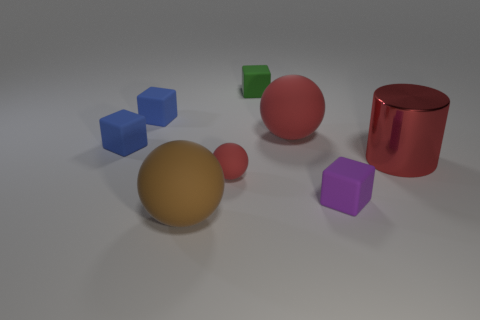Subtract all yellow blocks. How many red spheres are left? 2 Subtract all purple matte blocks. How many blocks are left? 3 Add 2 large brown rubber objects. How many objects exist? 10 Subtract all purple cubes. How many cubes are left? 3 Subtract all cylinders. How many objects are left? 7 Subtract 1 spheres. How many spheres are left? 2 Add 5 red cylinders. How many red cylinders are left? 6 Add 6 large brown matte balls. How many large brown matte balls exist? 7 Subtract 0 purple cylinders. How many objects are left? 8 Subtract all red cubes. Subtract all yellow cylinders. How many cubes are left? 4 